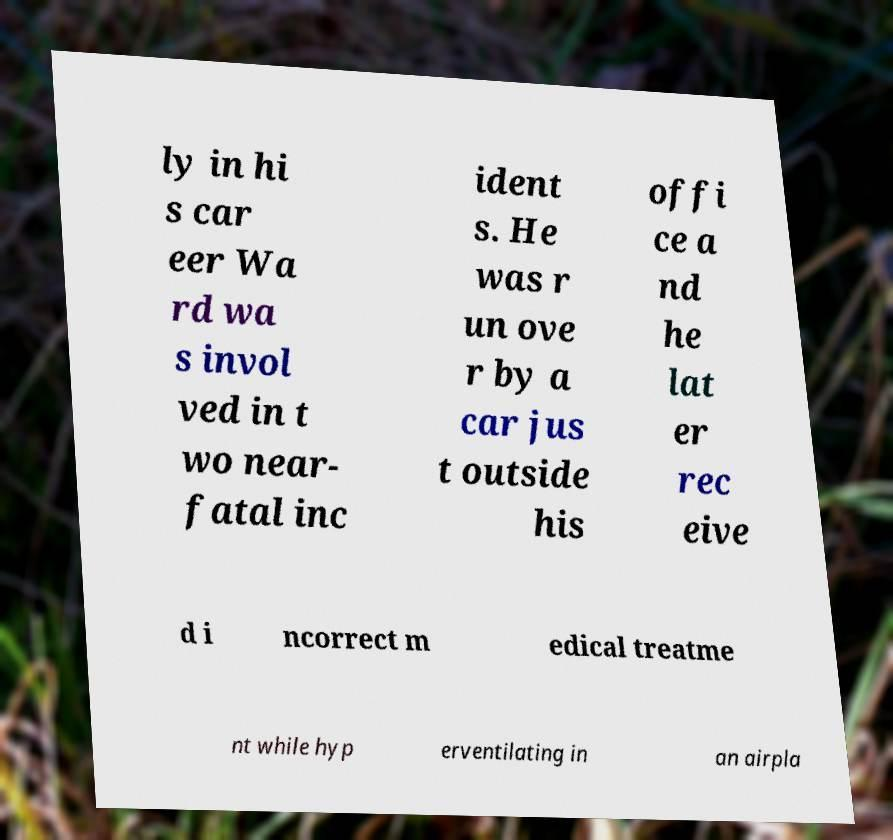What messages or text are displayed in this image? I need them in a readable, typed format. ly in hi s car eer Wa rd wa s invol ved in t wo near- fatal inc ident s. He was r un ove r by a car jus t outside his offi ce a nd he lat er rec eive d i ncorrect m edical treatme nt while hyp erventilating in an airpla 